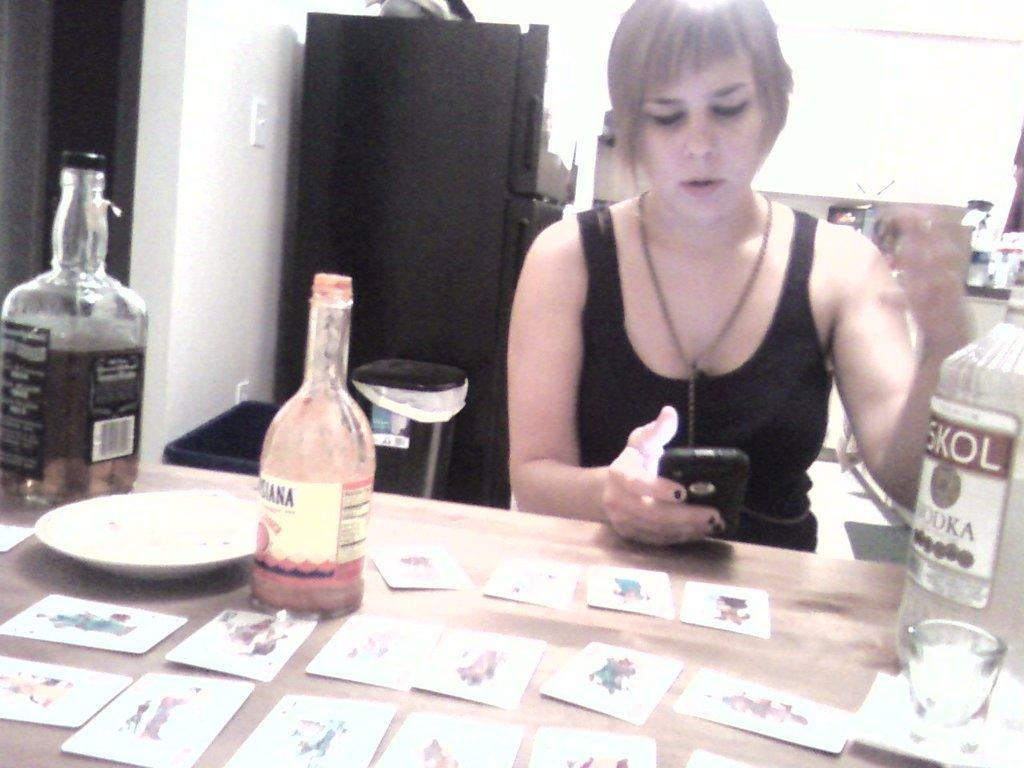Who is present in the image? There is a woman in the image. What is the woman doing in the image? The woman is sitting on a chair and looking at a mobile phone. What can be seen on the table in the image? There are wine bottles on a table. What type of thrill can be seen in the downtown lunchroom in the image? There is no downtown lunchroom or thrill present in the image; it features a woman sitting on a chair and looking at a mobile phone, with wine bottles on a table. 